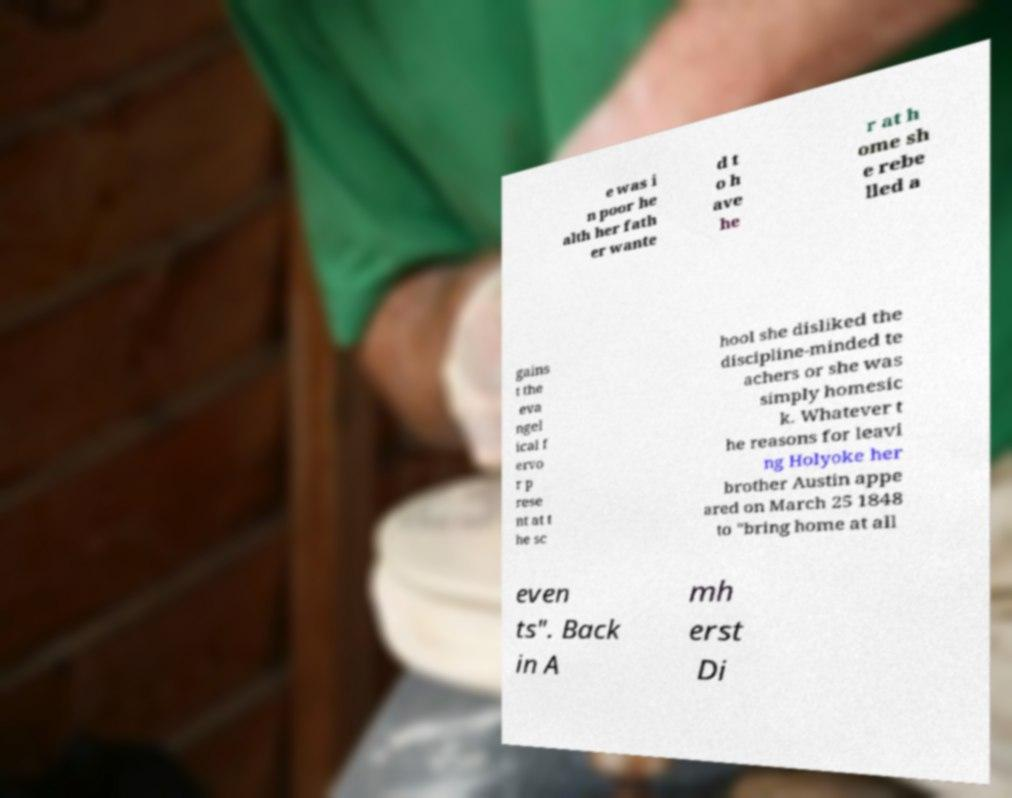Please read and relay the text visible in this image. What does it say? e was i n poor he alth her fath er wante d t o h ave he r at h ome sh e rebe lled a gains t the eva ngel ical f ervo r p rese nt at t he sc hool she disliked the discipline-minded te achers or she was simply homesic k. Whatever t he reasons for leavi ng Holyoke her brother Austin appe ared on March 25 1848 to "bring home at all even ts". Back in A mh erst Di 